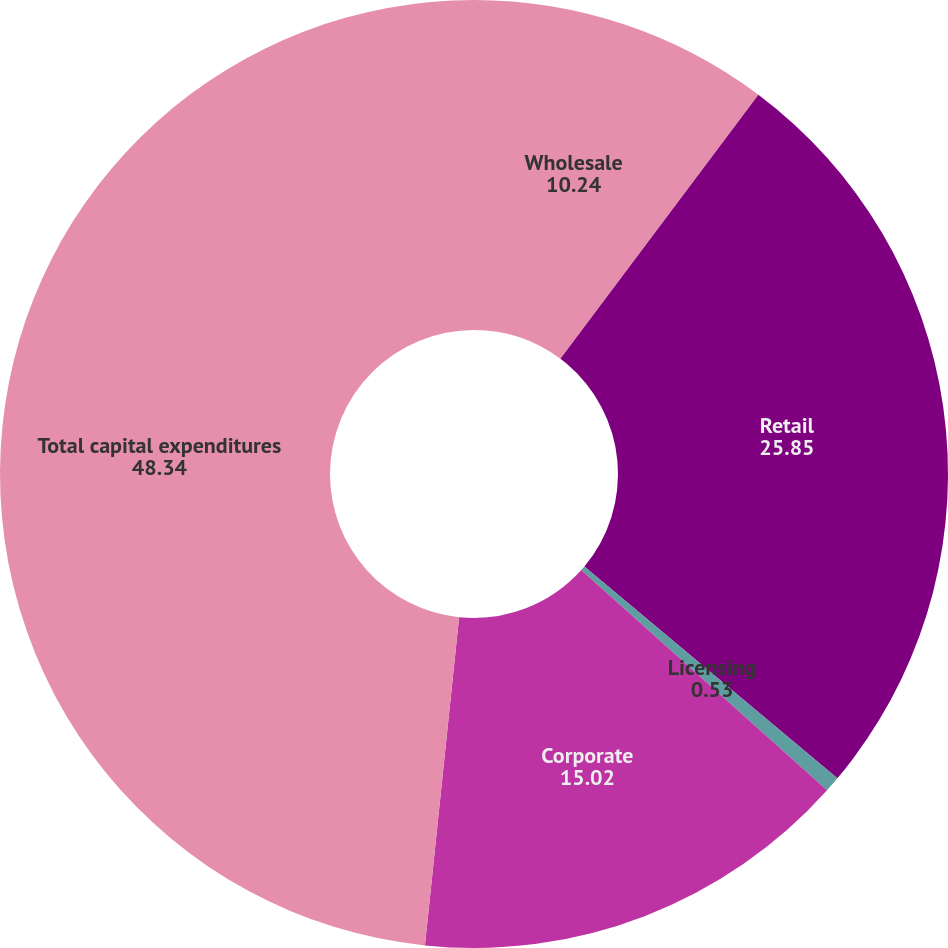Convert chart. <chart><loc_0><loc_0><loc_500><loc_500><pie_chart><fcel>Wholesale<fcel>Retail<fcel>Licensing<fcel>Corporate<fcel>Total capital expenditures<nl><fcel>10.24%<fcel>25.85%<fcel>0.53%<fcel>15.02%<fcel>48.34%<nl></chart> 